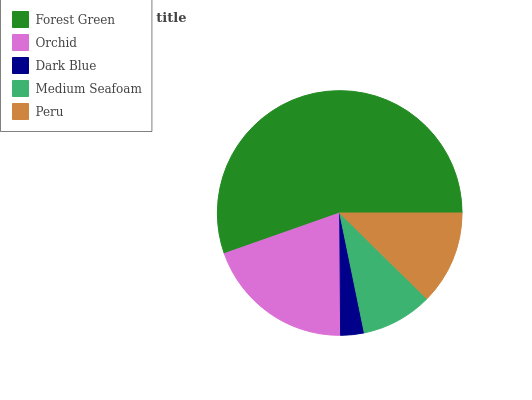Is Dark Blue the minimum?
Answer yes or no. Yes. Is Forest Green the maximum?
Answer yes or no. Yes. Is Orchid the minimum?
Answer yes or no. No. Is Orchid the maximum?
Answer yes or no. No. Is Forest Green greater than Orchid?
Answer yes or no. Yes. Is Orchid less than Forest Green?
Answer yes or no. Yes. Is Orchid greater than Forest Green?
Answer yes or no. No. Is Forest Green less than Orchid?
Answer yes or no. No. Is Peru the high median?
Answer yes or no. Yes. Is Peru the low median?
Answer yes or no. Yes. Is Dark Blue the high median?
Answer yes or no. No. Is Medium Seafoam the low median?
Answer yes or no. No. 